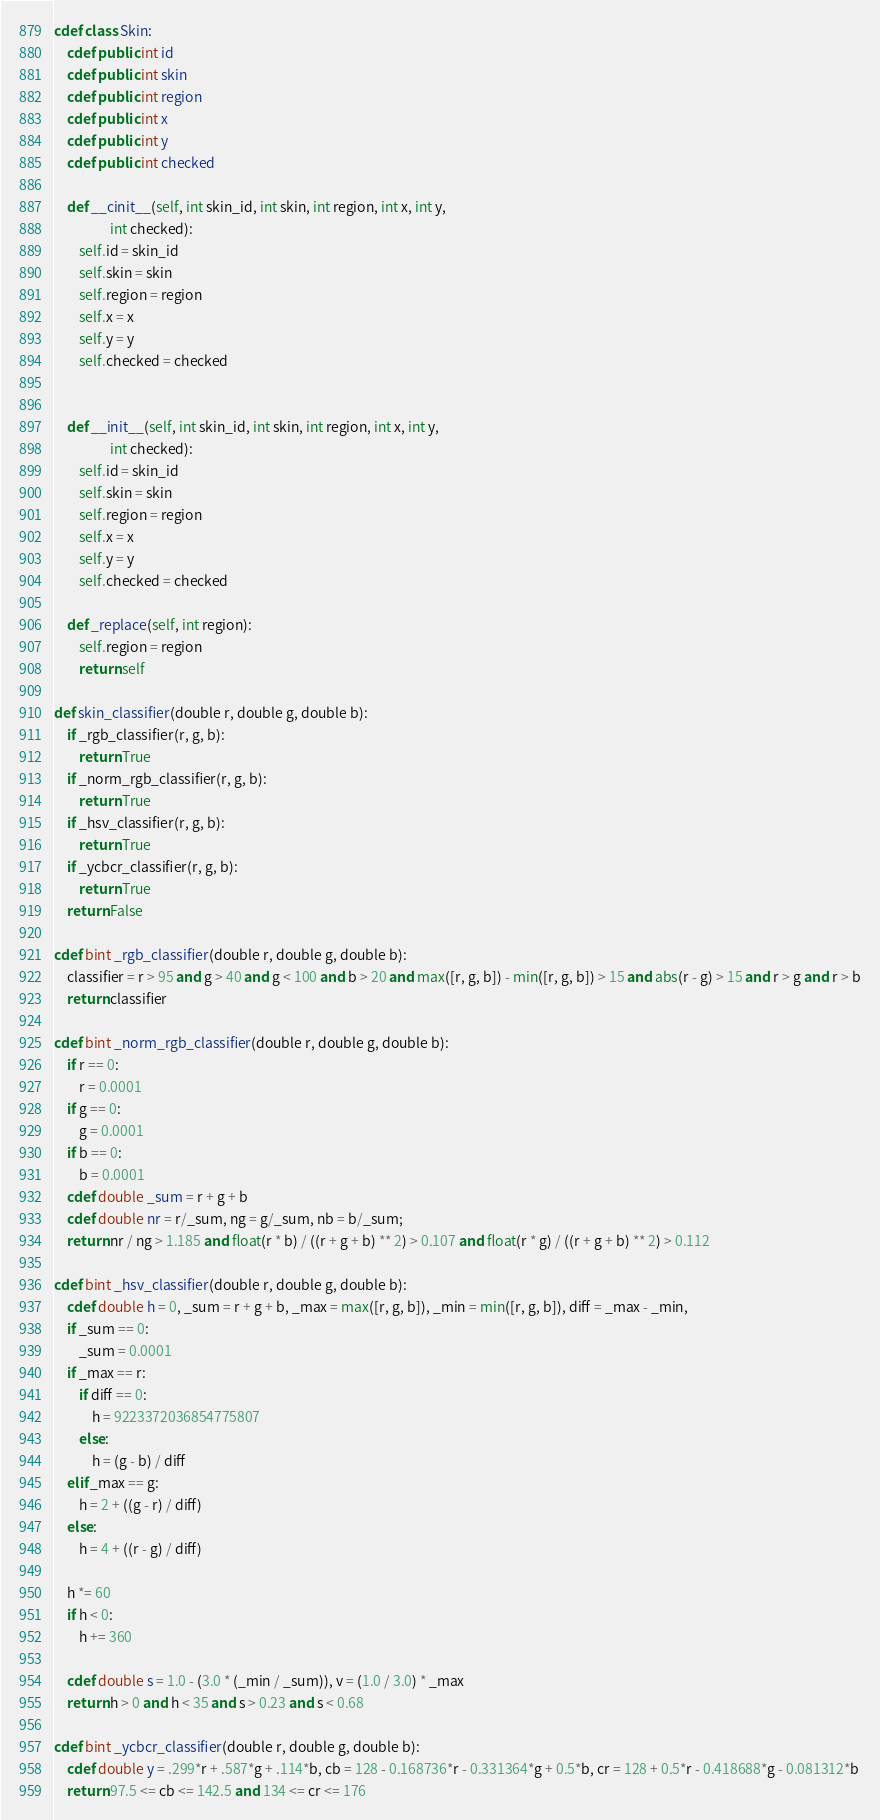<code> <loc_0><loc_0><loc_500><loc_500><_Cython_>

cdef class Skin:
    cdef public int id
    cdef public int skin
    cdef public int region
    cdef public int x
    cdef public int y
    cdef public int checked

    def __cinit__(self, int skin_id, int skin, int region, int x, int y,
                  int checked):
        self.id = skin_id
        self.skin = skin
        self.region = region
        self.x = x
        self.y = y
        self.checked = checked


    def __init__(self, int skin_id, int skin, int region, int x, int y,
                  int checked):
        self.id = skin_id
        self.skin = skin
        self.region = region
        self.x = x
        self.y = y
        self.checked = checked

    def _replace(self, int region):
        self.region = region
        return self

def skin_classifier(double r, double g, double b):
    if _rgb_classifier(r, g, b):
        return True
    if _norm_rgb_classifier(r, g, b):
        return True
    if _hsv_classifier(r, g, b):
        return True
    if _ycbcr_classifier(r, g, b):
        return True
    return False

cdef bint _rgb_classifier(double r, double g, double b):
    classifier = r > 95 and g > 40 and g < 100 and b > 20 and max([r, g, b]) - min([r, g, b]) > 15 and abs(r - g) > 15 and r > g and r > b
    return classifier

cdef bint _norm_rgb_classifier(double r, double g, double b):
    if r == 0:
        r = 0.0001
    if g == 0:
        g = 0.0001
    if b == 0:
        b = 0.0001
    cdef double _sum = r + g + b
    cdef double nr = r/_sum, ng = g/_sum, nb = b/_sum;
    return nr / ng > 1.185 and float(r * b) / ((r + g + b) ** 2) > 0.107 and float(r * g) / ((r + g + b) ** 2) > 0.112

cdef bint _hsv_classifier(double r, double g, double b):
    cdef double h = 0, _sum = r + g + b, _max = max([r, g, b]), _min = min([r, g, b]), diff = _max - _min,
    if _sum == 0:
        _sum = 0.0001
    if _max == r:
        if diff == 0:
            h = 9223372036854775807
        else:
            h = (g - b) / diff
    elif _max == g:
        h = 2 + ((g - r) / diff)
    else:
        h = 4 + ((r - g) / diff)

    h *= 60
    if h < 0:
        h += 360

    cdef double s = 1.0 - (3.0 * (_min / _sum)), v = (1.0 / 3.0) * _max
    return h > 0 and h < 35 and s > 0.23 and s < 0.68

cdef bint _ycbcr_classifier(double r, double g, double b):
    cdef double y = .299*r + .587*g + .114*b, cb = 128 - 0.168736*r - 0.331364*g + 0.5*b, cr = 128 + 0.5*r - 0.418688*g - 0.081312*b
    return 97.5 <= cb <= 142.5 and 134 <= cr <= 176




</code> 